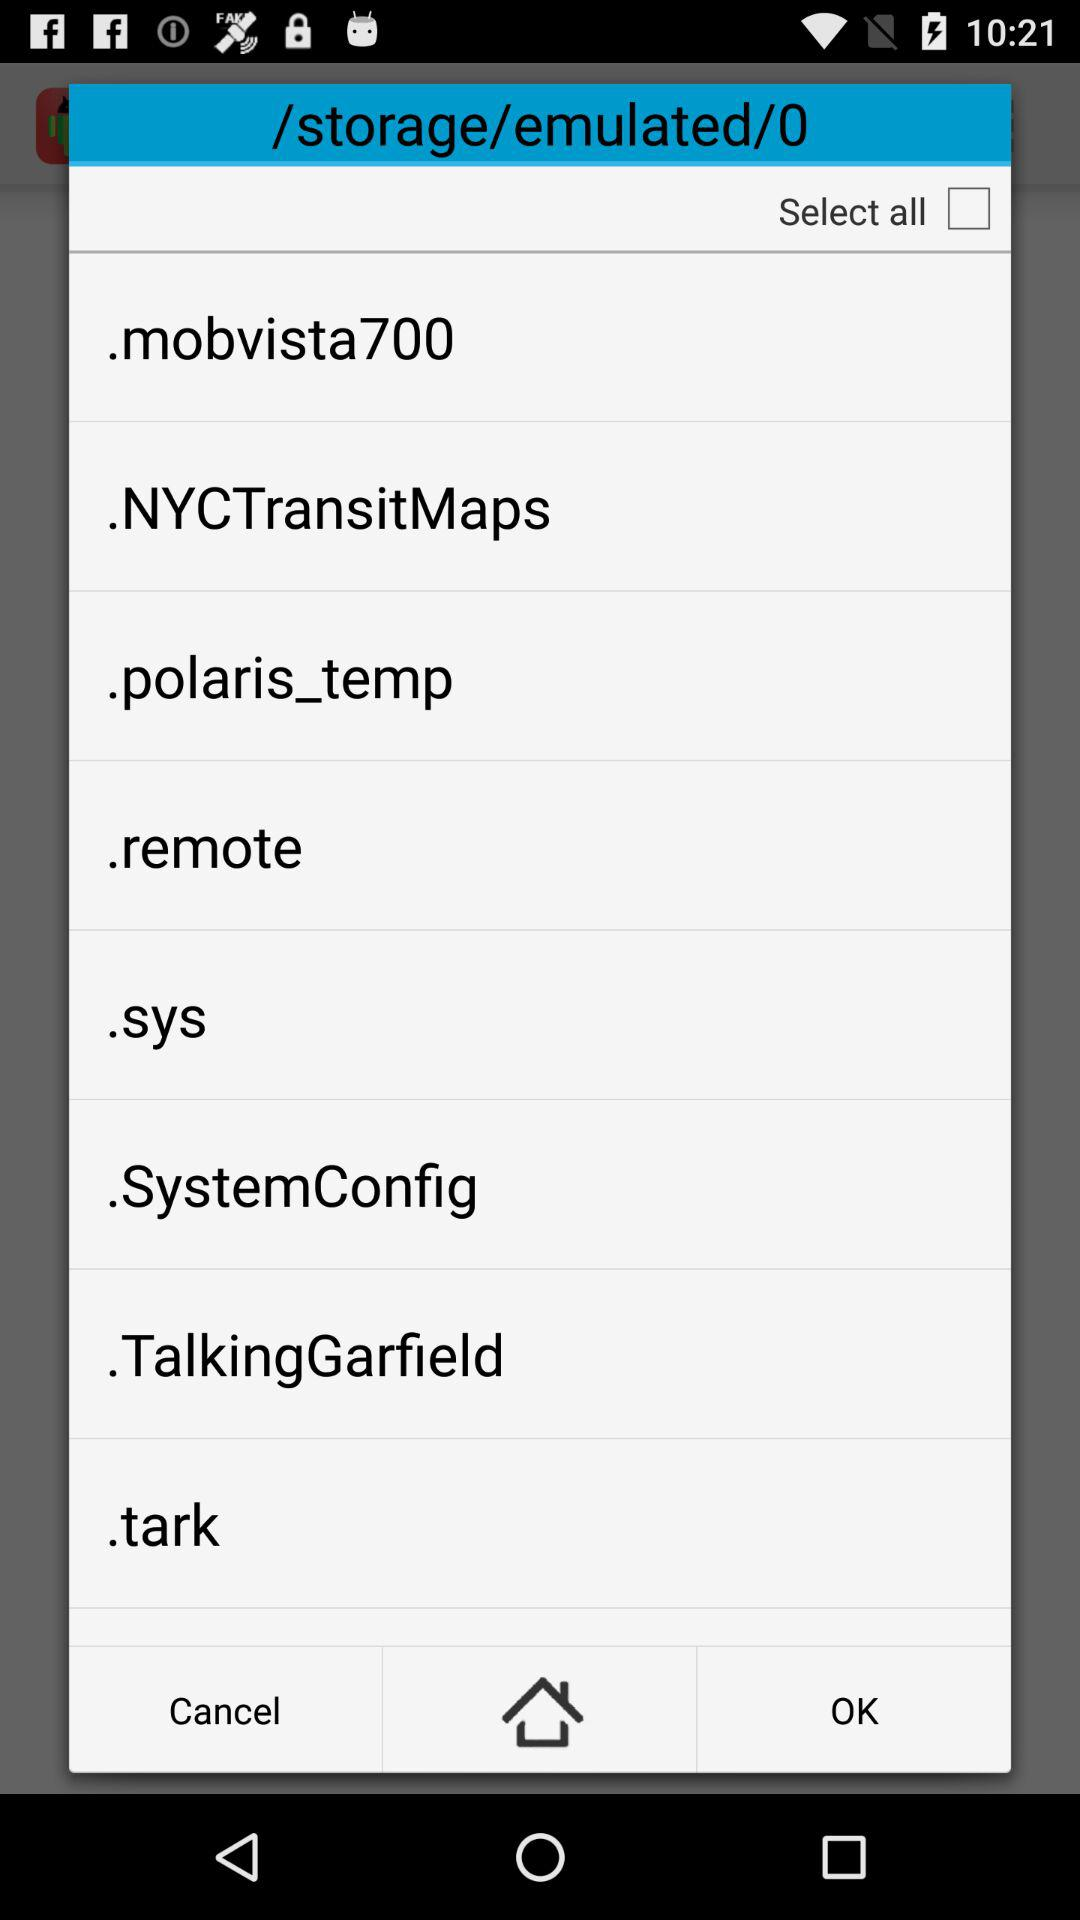What is the status of "Select all"? The status is "off". 